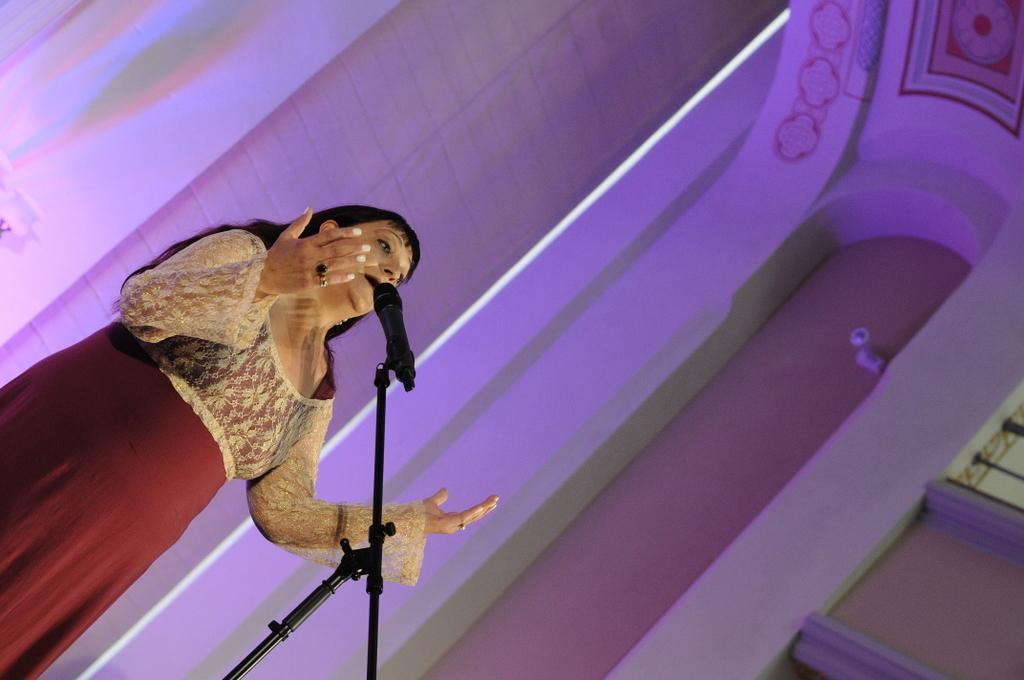Describe this image in one or two sentences. In this picture we can see a woman is standing and speaking something, there is a microphone in front of her, in the background there is a wall. 